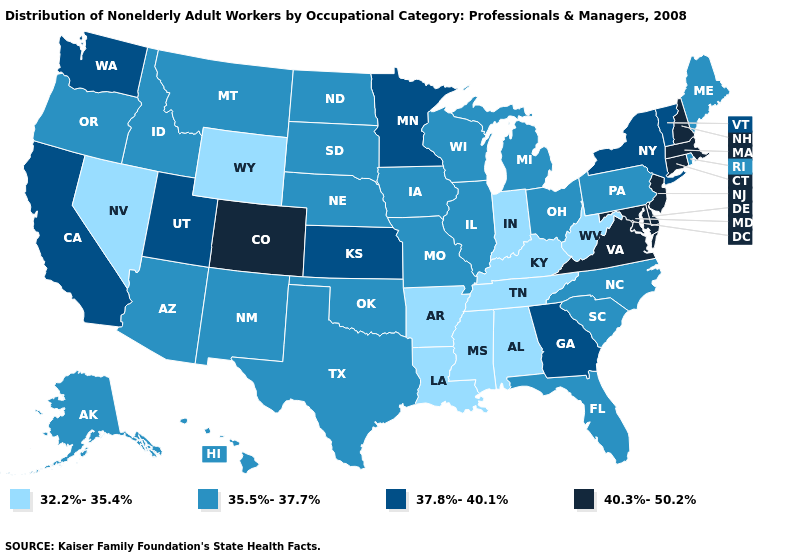Does New Mexico have a lower value than New Hampshire?
Keep it brief. Yes. Which states have the lowest value in the MidWest?
Answer briefly. Indiana. What is the value of Nebraska?
Write a very short answer. 35.5%-37.7%. What is the lowest value in the USA?
Give a very brief answer. 32.2%-35.4%. Among the states that border Florida , does Georgia have the highest value?
Be succinct. Yes. Among the states that border Florida , does Georgia have the highest value?
Be succinct. Yes. Which states have the lowest value in the USA?
Concise answer only. Alabama, Arkansas, Indiana, Kentucky, Louisiana, Mississippi, Nevada, Tennessee, West Virginia, Wyoming. What is the value of North Carolina?
Be succinct. 35.5%-37.7%. How many symbols are there in the legend?
Short answer required. 4. Name the states that have a value in the range 37.8%-40.1%?
Give a very brief answer. California, Georgia, Kansas, Minnesota, New York, Utah, Vermont, Washington. What is the value of Colorado?
Write a very short answer. 40.3%-50.2%. What is the value of Washington?
Write a very short answer. 37.8%-40.1%. What is the highest value in the South ?
Write a very short answer. 40.3%-50.2%. Among the states that border South Carolina , does Georgia have the lowest value?
Concise answer only. No. Name the states that have a value in the range 32.2%-35.4%?
Short answer required. Alabama, Arkansas, Indiana, Kentucky, Louisiana, Mississippi, Nevada, Tennessee, West Virginia, Wyoming. 